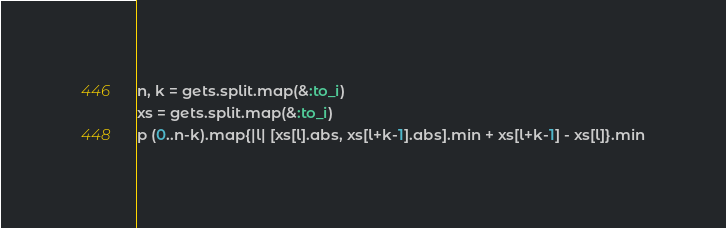Convert code to text. <code><loc_0><loc_0><loc_500><loc_500><_Ruby_>n, k = gets.split.map(&:to_i)
xs = gets.split.map(&:to_i)
p (0..n-k).map{|l| [xs[l].abs, xs[l+k-1].abs].min + xs[l+k-1] - xs[l]}.min</code> 